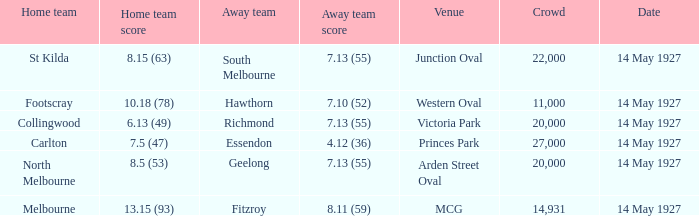What was the home team when the Geelong away team had a score of 7.13 (55)? North Melbourne. 